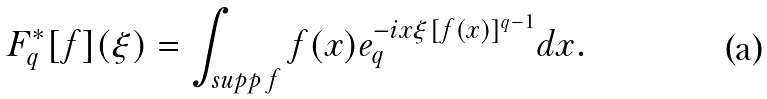<formula> <loc_0><loc_0><loc_500><loc_500>F _ { q } ^ { \ast } [ f ] ( \xi ) = \int _ { s u p p \, f } f ( x ) e _ { q } ^ { - i x \xi [ f ( x ) ] ^ { q - 1 } } d x .</formula> 